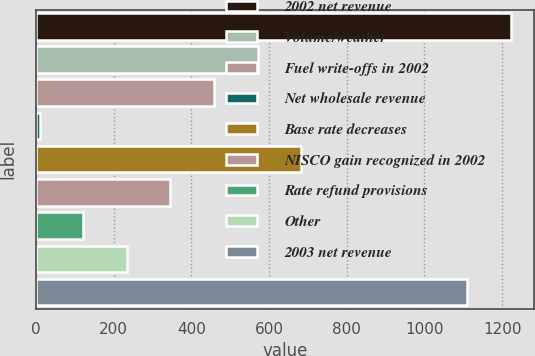<chart> <loc_0><loc_0><loc_500><loc_500><bar_chart><fcel>2002 net revenue<fcel>Volume/weather<fcel>Fuel write-offs in 2002<fcel>Net wholesale revenue<fcel>Base rate decreases<fcel>NISCO gain recognized in 2002<fcel>Rate refund provisions<fcel>Other<fcel>2003 net revenue<nl><fcel>1222.15<fcel>570.45<fcel>458.4<fcel>10.2<fcel>682.5<fcel>346.35<fcel>122.25<fcel>234.3<fcel>1110.1<nl></chart> 